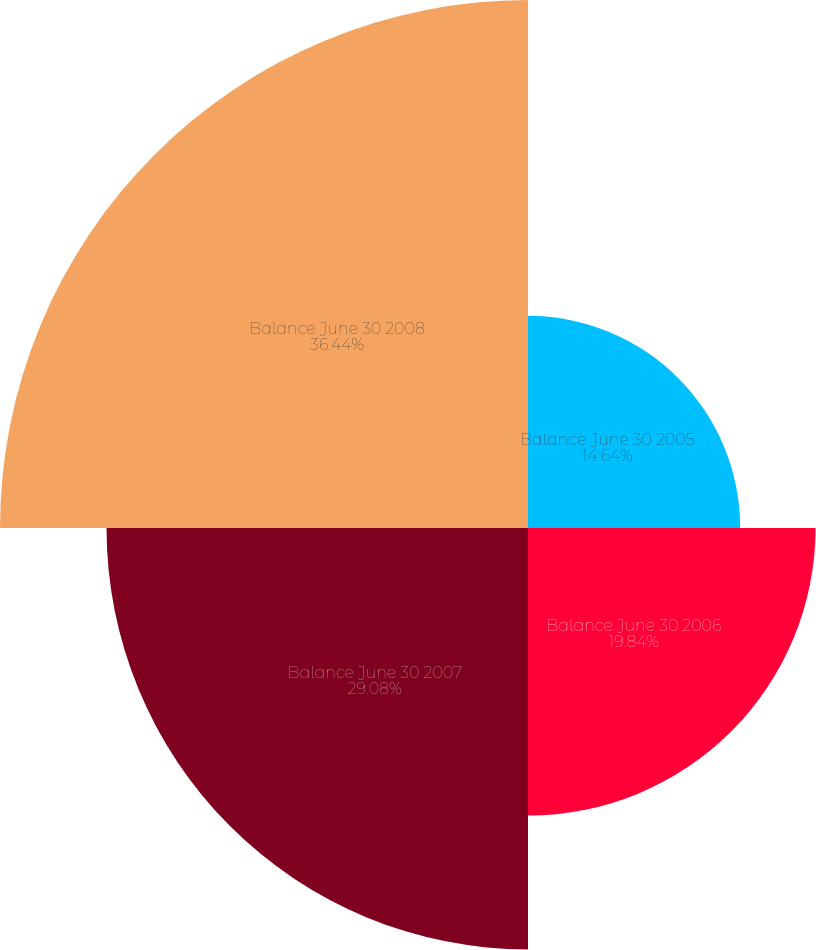<chart> <loc_0><loc_0><loc_500><loc_500><pie_chart><fcel>Balance June 30 2005<fcel>Balance June 30 2006<fcel>Balance June 30 2007<fcel>Balance June 30 2008<nl><fcel>14.64%<fcel>19.84%<fcel>29.08%<fcel>36.43%<nl></chart> 